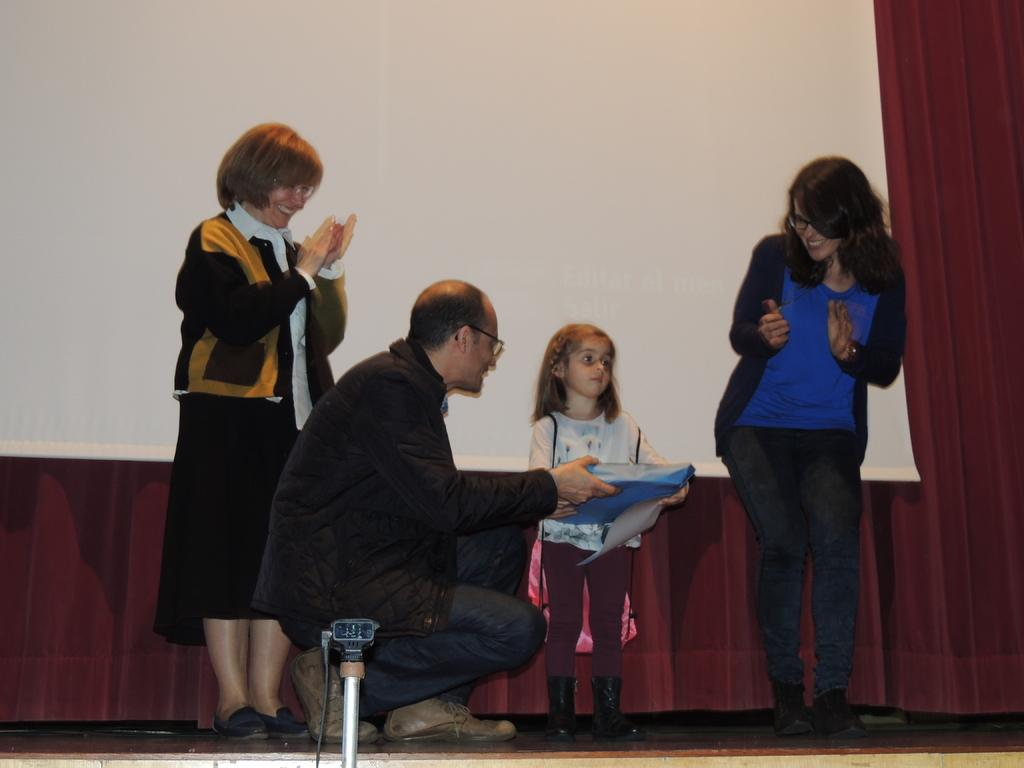How many people are in the image? There are persons standing in the image. What surface are the persons standing on? The persons are standing on the floor. What can be seen in the background of the image? There are curtains and a screen in the background of the image. What type of statement is being made by the shoe in the image? There is no shoe present in the image, so it is not possible to answer that question. 